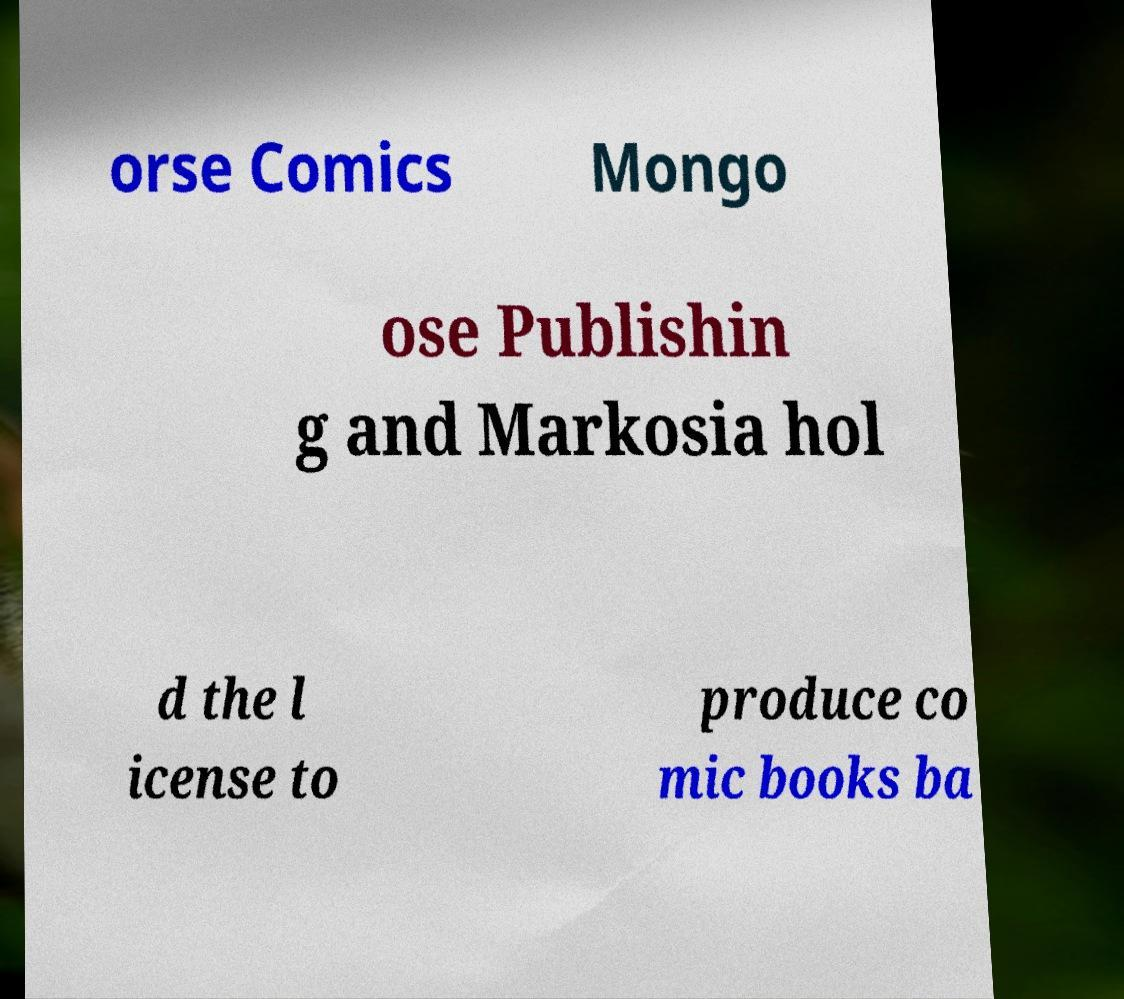Please read and relay the text visible in this image. What does it say? orse Comics Mongo ose Publishin g and Markosia hol d the l icense to produce co mic books ba 